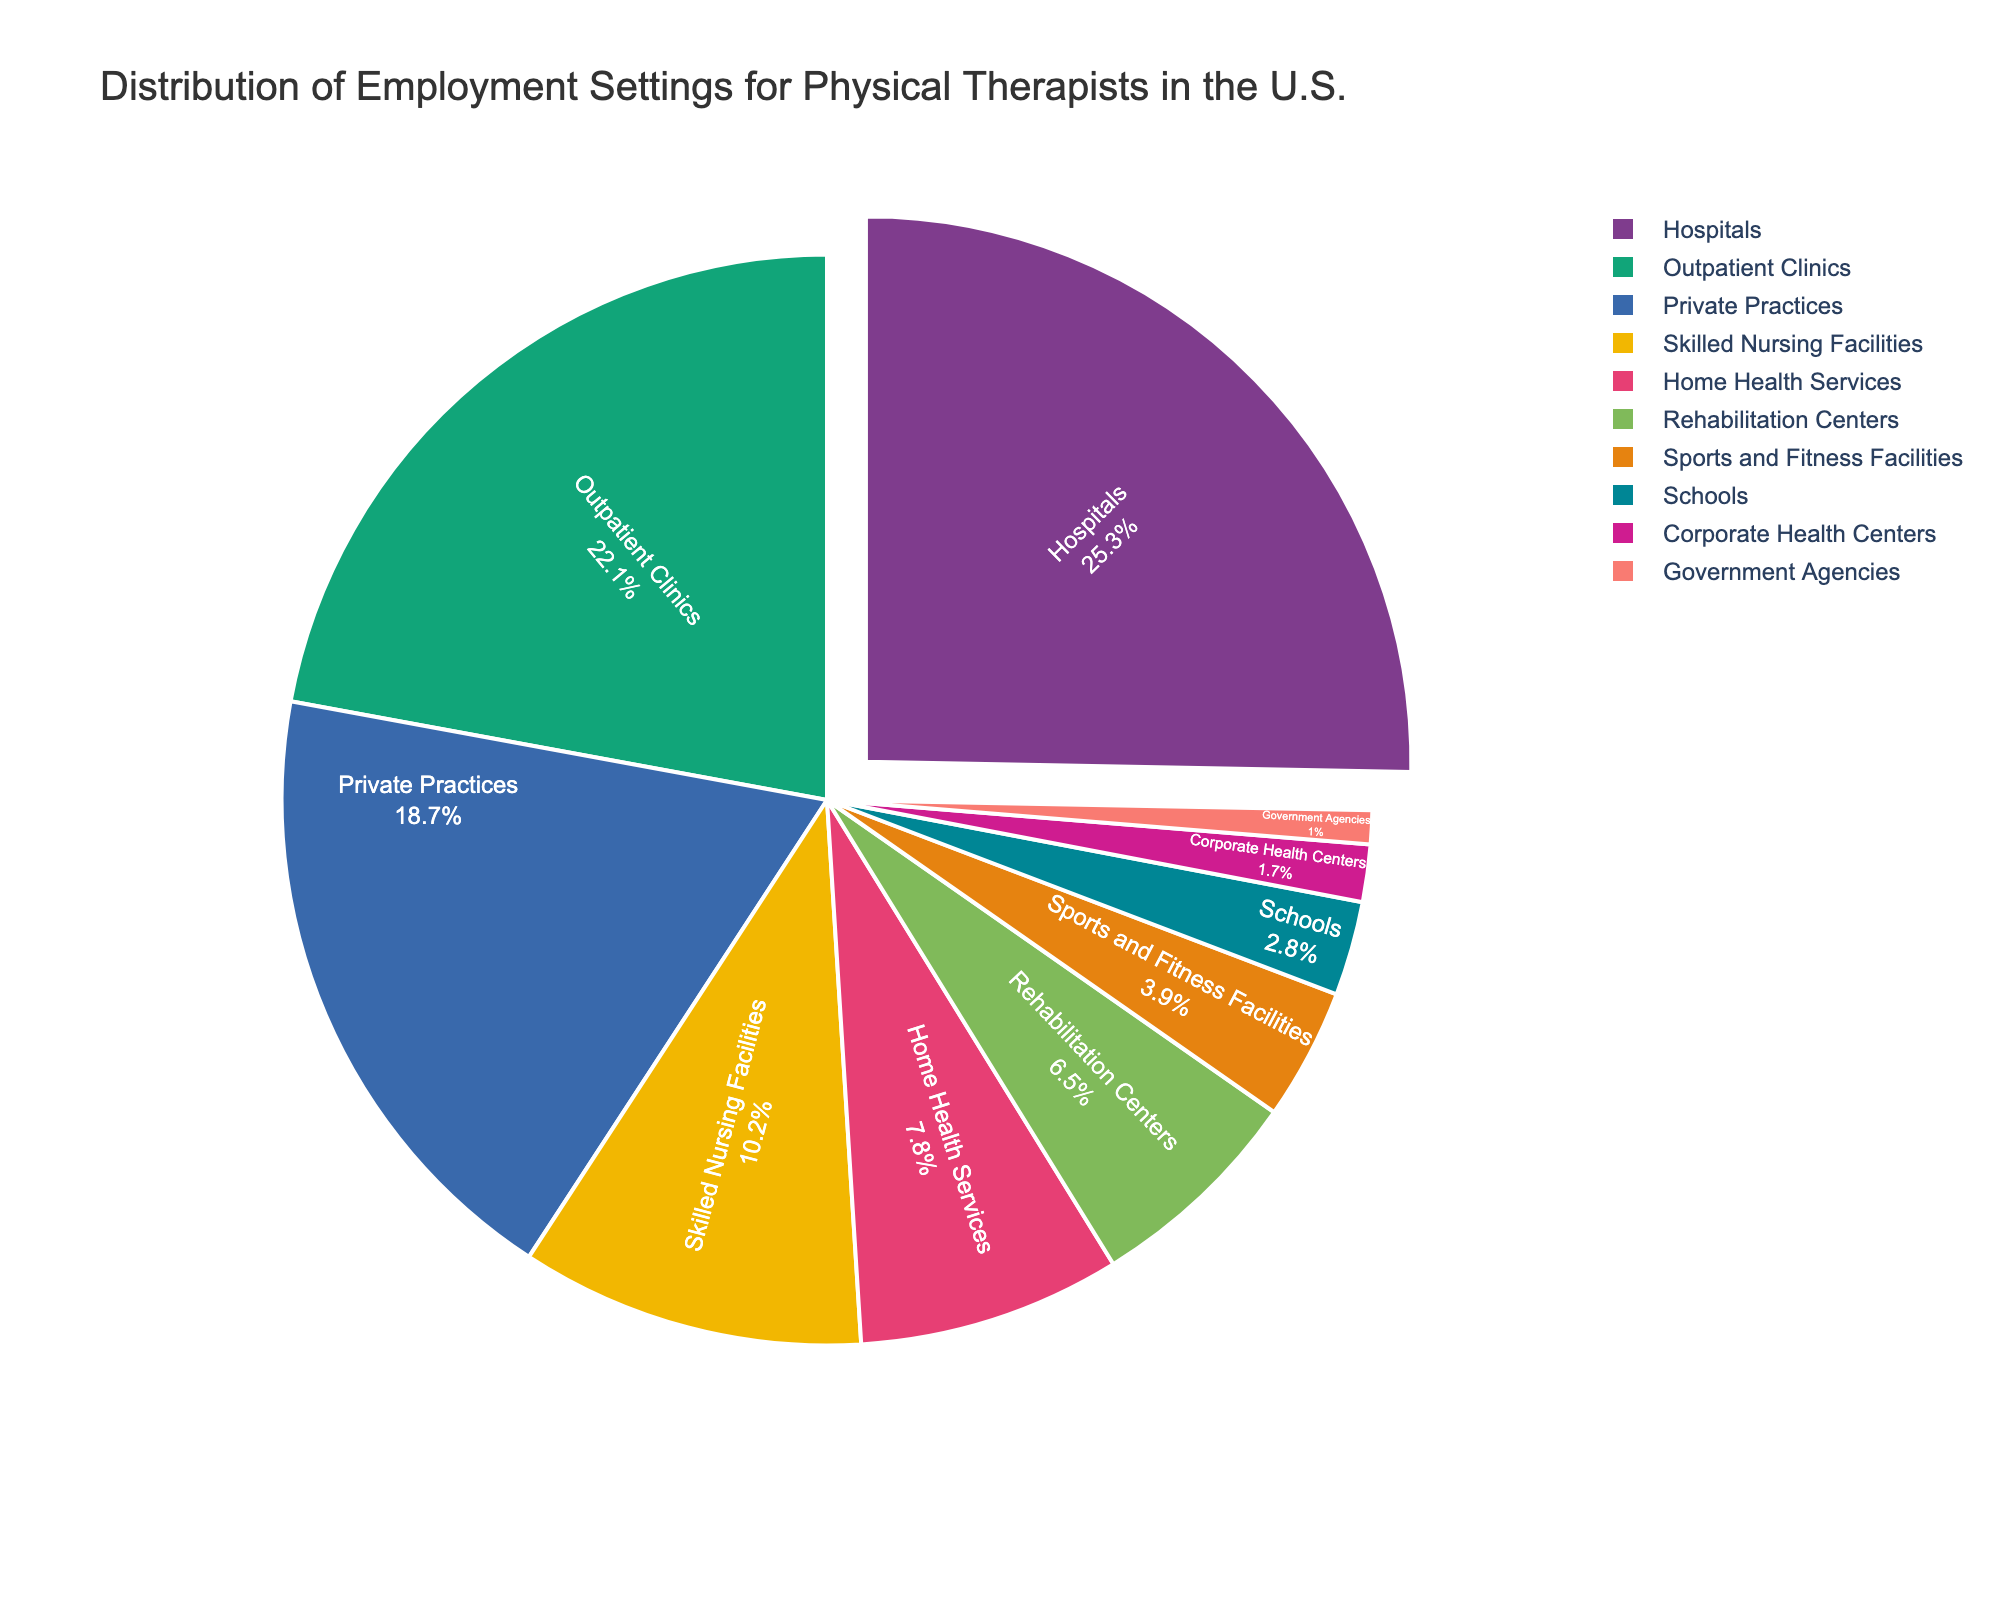what is the most common employment setting for physical therapists in the U.S.? The pie chart shows different employment settings with their respective percentages. The largest segment represents the most common setting, which is "Hospitals" with 25.3%.
Answer: Hospitals Which employment setting has the smallest percentage for physical therapists in the U.S.? The smallest segment in the pie chart represents the least common setting, which is "Government Agencies" at 1.0%.
Answer: Government Agencies What's the combined percentage of physical therapists working in outpatient clinics and private practices? The percentage for outpatient clinics is 22.1% and for private practices is 18.7%. Adding them together: 22.1 + 18.7 = 40.8%.
Answer: 40.8% How much more do physical therapists work in skilled nursing facilities compared to schools? The percentage for skilled nursing facilities is 10.2% and for schools is 2.8%. The difference is 10.2 - 2.8 = 7.4%.
Answer: 7.4% Compare the employment percentages of home health services and sports and fitness facilities. Which is higher and by how much? Home health services have a percentage of 7.8%, and sports and fitness facilities have 3.9%. The difference is 7.8 - 3.9 = 3.9%. So, home health services are higher by 3.9%.
Answer: Home health services; 3.9% What's the total percentage of physical therapists employed in rehabilitation centers, schools, and corporate health centers combined? The percentages are 6.5% for rehabilitation centers, 2.8% for schools, and 1.7% for corporate health centers. Adding them together: 6.5 + 2.8 + 1.7 = 11.0%.
Answer: 11.0% How do the employment percentages of government agencies compare to corporate health centers? Government agencies have a percentage of 1.0%, and corporate health centers have 1.7%. Corporate health centers have a higher percentage by 0.7%.
Answer: Corporate health centers; 0.7% Which employment settings have percentages greater than 10%, and what is their combined percentage? The settings with percentages greater than 10% are hospitals (25.3%), outpatient clinics (22.1%), and skilled nursing facilities (10.2%). Their combined percentage is 25.3 + 22.1 + 10.2 = 57.6%.
Answer: Hospitals, outpatient clinics, skilled nursing facilities; 57.6% What's the difference in employment percentage between private practices and skilled nursing facilities? The percentage for private practices is 18.7%, and for skilled nursing facilities, it is 10.2%. The difference is 18.7 - 10.2 = 8.5%.
Answer: 8.5% 